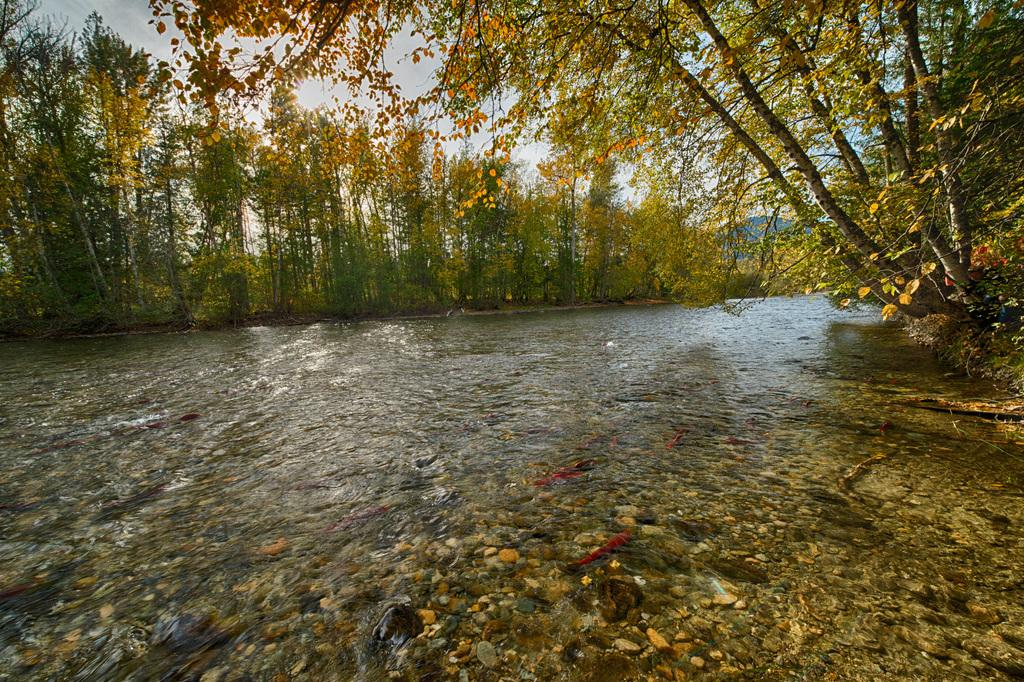What is the primary element visible in the image? There is water in the image. What other objects or features can be seen in the image? There are stones, trees, and hills visible in the image. What is visible at the top of the image? The sky is visible at the top of the image. How many potatoes can be seen growing in the image? There are no potatoes visible in the image. What is the daughter doing in the image? There is no mention of a daughter or any person in the image. 